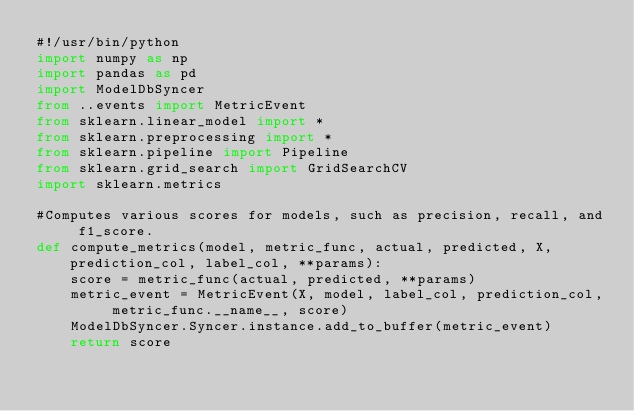Convert code to text. <code><loc_0><loc_0><loc_500><loc_500><_Python_>#!/usr/bin/python
import numpy as np
import pandas as pd
import ModelDbSyncer
from ..events import MetricEvent
from sklearn.linear_model import *
from sklearn.preprocessing import *
from sklearn.pipeline import Pipeline
from sklearn.grid_search import GridSearchCV
import sklearn.metrics

#Computes various scores for models, such as precision, recall, and f1_score.
def compute_metrics(model, metric_func, actual, predicted, X, prediction_col, label_col, **params):
    score = metric_func(actual, predicted, **params)
    metric_event = MetricEvent(X, model, label_col, prediction_col, metric_func.__name__, score)
    ModelDbSyncer.Syncer.instance.add_to_buffer(metric_event)
    return score
</code> 